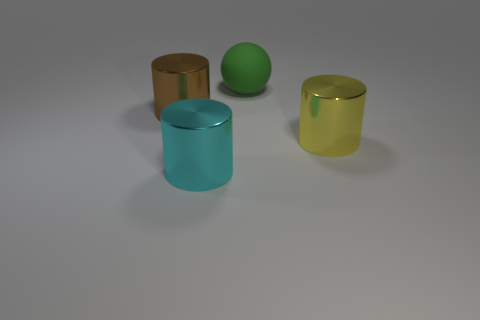Does the metallic cylinder that is behind the big yellow thing have the same size as the metal object in front of the yellow metallic cylinder?
Your response must be concise. Yes. What number of yellow objects have the same material as the big brown cylinder?
Ensure brevity in your answer.  1. There is a big metallic cylinder that is on the right side of the big thing behind the large brown thing; how many cyan metallic objects are behind it?
Offer a terse response. 0. Is the shape of the big cyan object the same as the big green matte object?
Your response must be concise. No. Is there a tiny brown metal thing that has the same shape as the big yellow metallic thing?
Make the answer very short. No. There is a brown thing that is the same size as the cyan cylinder; what is its shape?
Provide a short and direct response. Cylinder. There is a large cylinder that is on the right side of the big cylinder that is in front of the metal thing to the right of the ball; what is its material?
Give a very brief answer. Metal. Does the green thing have the same size as the yellow metallic cylinder?
Offer a very short reply. Yes. What is the big brown thing made of?
Your response must be concise. Metal. Does the big metal object that is on the right side of the green object have the same shape as the large cyan metal thing?
Give a very brief answer. Yes. 